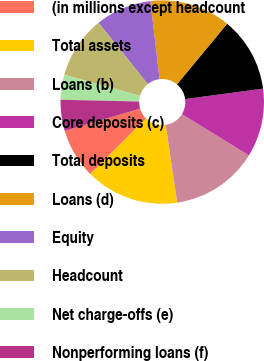<chart> <loc_0><loc_0><loc_500><loc_500><pie_chart><fcel>(in millions except headcount<fcel>Total assets<fcel>Loans (b)<fcel>Core deposits (c)<fcel>Total deposits<fcel>Loans (d)<fcel>Equity<fcel>Headcount<fcel>Net charge-offs (e)<fcel>Nonperforming loans (f)<nl><fcel>7.92%<fcel>14.85%<fcel>13.86%<fcel>10.89%<fcel>11.88%<fcel>12.87%<fcel>8.91%<fcel>9.9%<fcel>3.96%<fcel>4.95%<nl></chart> 